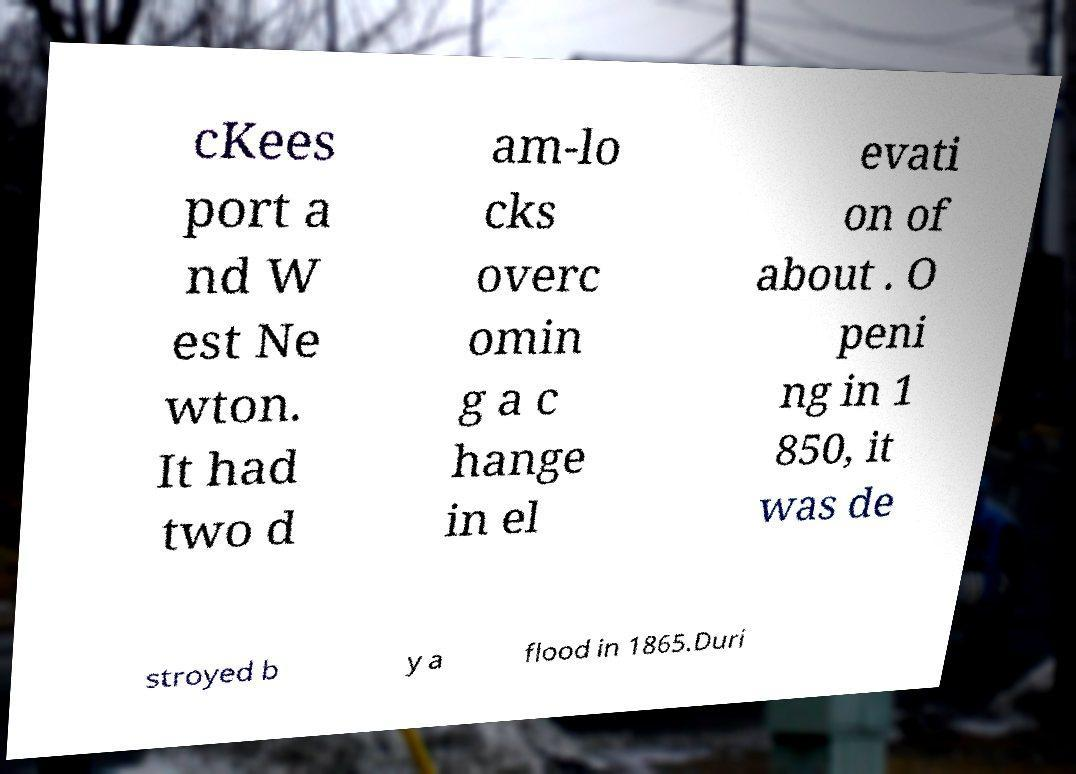Could you assist in decoding the text presented in this image and type it out clearly? cKees port a nd W est Ne wton. It had two d am-lo cks overc omin g a c hange in el evati on of about . O peni ng in 1 850, it was de stroyed b y a flood in 1865.Duri 